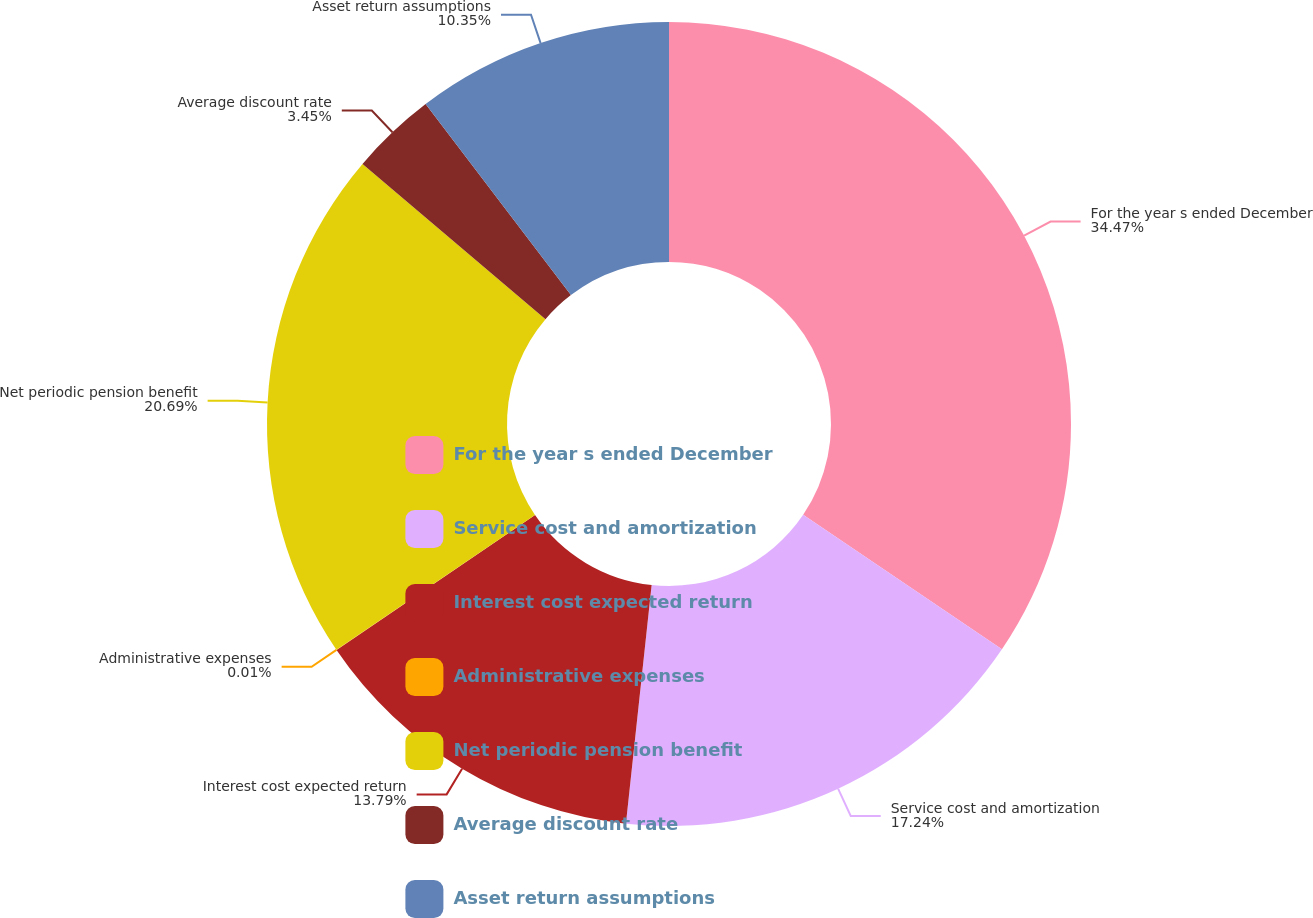Convert chart to OTSL. <chart><loc_0><loc_0><loc_500><loc_500><pie_chart><fcel>For the year s ended December<fcel>Service cost and amortization<fcel>Interest cost expected return<fcel>Administrative expenses<fcel>Net periodic pension benefit<fcel>Average discount rate<fcel>Asset return assumptions<nl><fcel>34.47%<fcel>17.24%<fcel>13.79%<fcel>0.01%<fcel>20.69%<fcel>3.45%<fcel>10.35%<nl></chart> 